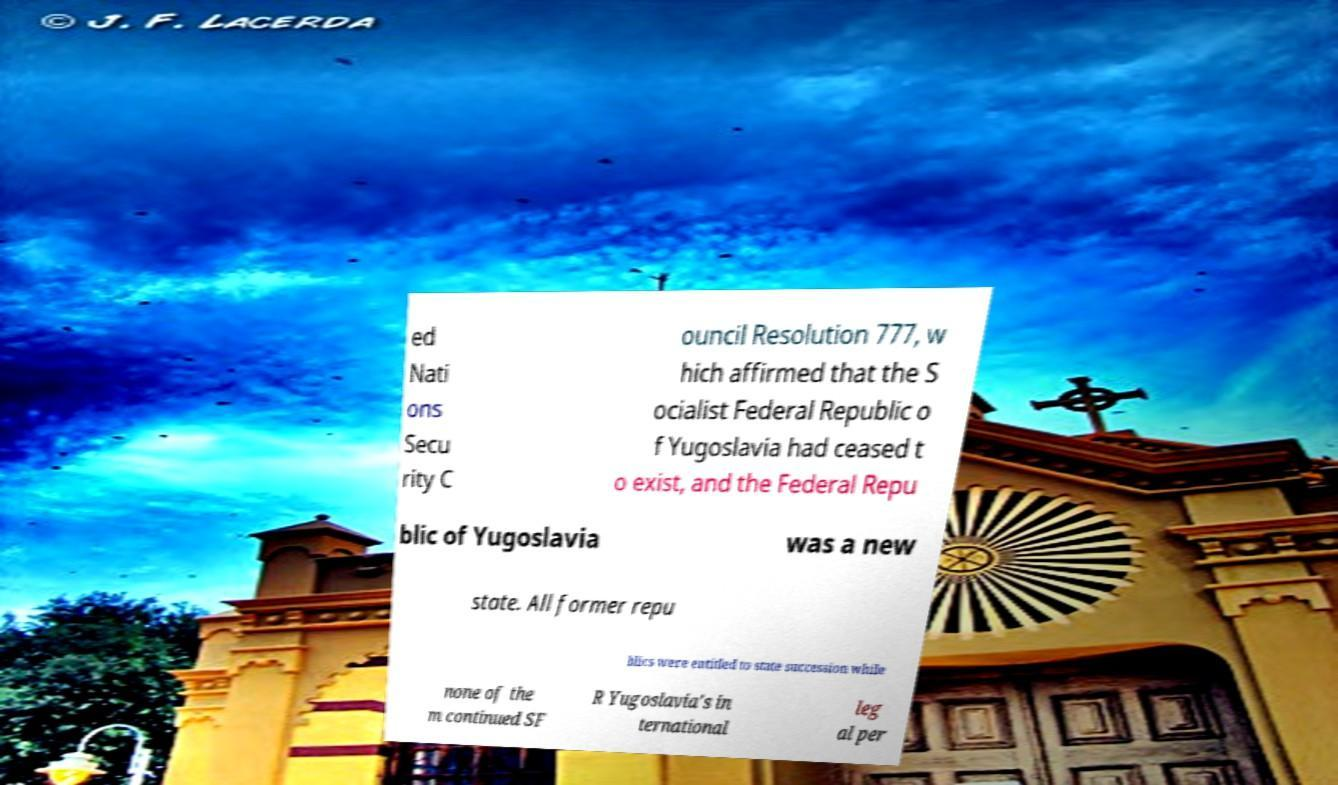Can you read and provide the text displayed in the image?This photo seems to have some interesting text. Can you extract and type it out for me? ed Nati ons Secu rity C ouncil Resolution 777, w hich affirmed that the S ocialist Federal Republic o f Yugoslavia had ceased t o exist, and the Federal Repu blic of Yugoslavia was a new state. All former repu blics were entitled to state succession while none of the m continued SF R Yugoslavia's in ternational leg al per 